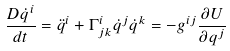Convert formula to latex. <formula><loc_0><loc_0><loc_500><loc_500>\frac { D \dot { q } ^ { i } } { d t } = \ddot { q } ^ { i } + \Gamma _ { j k } ^ { i } \dot { q } ^ { j } \dot { q } ^ { k } = - g ^ { i j } \frac { \partial U } { \partial q ^ { j } }</formula> 